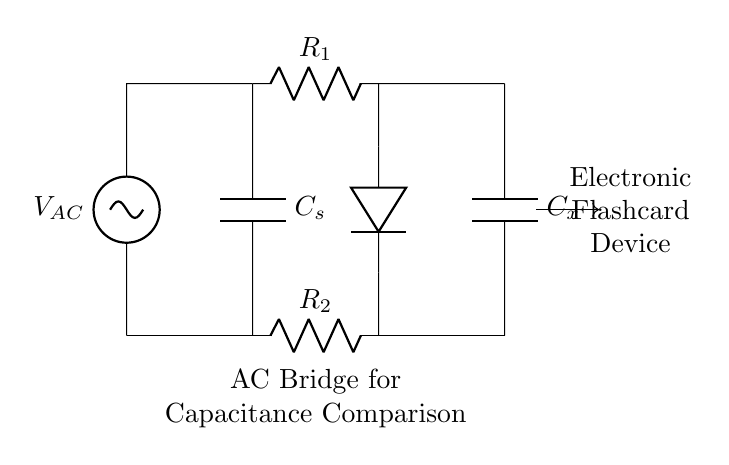What type of circuit is shown? The circuit is an AC bridge circuit, which is designed for comparing capacitances. This is evident from the arrangement and the components labeled for capacitance comparison.
Answer: AC bridge What is the AC voltage source symbol in the circuit? The AC voltage source is represented by the symbol 'V' with a tilde (~) next to it, indicating that it provides alternating current. This can be identified at the left side of the diagram.
Answer: V AC Which component is used for capacitance comparison? The component used for capacitance comparison is the capacitor labeled 'C_x' in the diagram, which is connected to the bridge. It can be found at the right side of the bridge configuration.
Answer: C_x What is the purpose of the resistors R_1 and R_2? Resistors R_1 and R_2 are used to balance the bridge circuit. The values of these resistors help in achieving a condition where the voltage across the bridge measure zero, indicating that the capacitances are equal.
Answer: To balance the bridge What happens when C_x is equal to C_s? When C_x is equal to C_s, the bridge is balanced, and the galvanometer (represented as the diode symbol in the diagram) reads zero. This condition occurs when the voltages across the two branches are equal due to the matching capacitances.
Answer: The bridge is balanced What does the diode in the circuit represent? The diode in the circuit represents the measuring device that indicates the balance of the bridge. If the diode conducts, it means the bridge is unbalanced and needs adjustment. This helps to determine equality between C_x and C_s.
Answer: Measuring device 